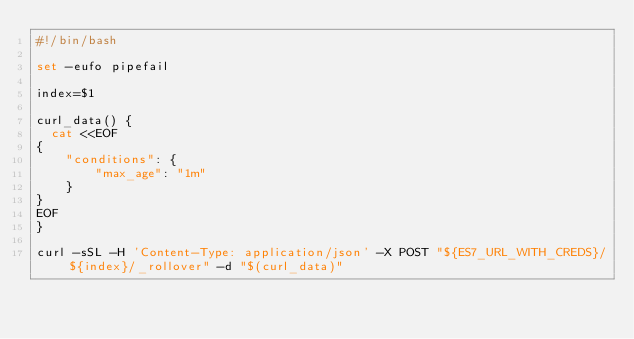Convert code to text. <code><loc_0><loc_0><loc_500><loc_500><_Bash_>#!/bin/bash

set -eufo pipefail

index=$1

curl_data() {
  cat <<EOF
{
    "conditions": {
        "max_age": "1m"
    }
}
EOF
}

curl -sSL -H 'Content-Type: application/json' -X POST "${ES7_URL_WITH_CREDS}/${index}/_rollover" -d "$(curl_data)"
</code> 